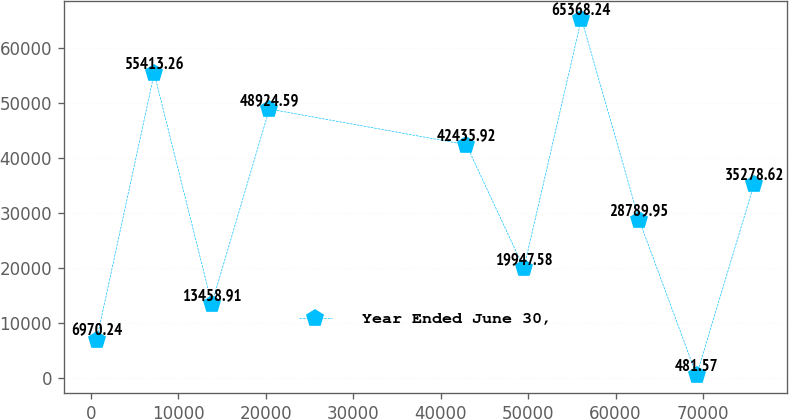<chart> <loc_0><loc_0><loc_500><loc_500><line_chart><ecel><fcel>Year Ended June 30,<nl><fcel>683.03<fcel>6970.24<nl><fcel>7262.53<fcel>55413.3<nl><fcel>13842<fcel>13458.9<nl><fcel>20421.5<fcel>48924.6<nl><fcel>42936.8<fcel>42435.9<nl><fcel>49516.2<fcel>19947.6<nl><fcel>56095.8<fcel>65368.2<nl><fcel>62675.2<fcel>28790<nl><fcel>69254.8<fcel>481.57<nl><fcel>75834.2<fcel>35278.6<nl></chart> 